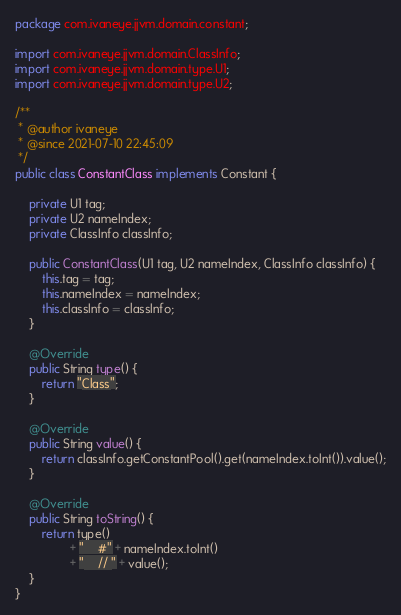<code> <loc_0><loc_0><loc_500><loc_500><_Java_>package com.ivaneye.jjvm.domain.constant;

import com.ivaneye.jjvm.domain.ClassInfo;
import com.ivaneye.jjvm.domain.type.U1;
import com.ivaneye.jjvm.domain.type.U2;

/**
 * @author ivaneye
 * @since 2021-07-10 22:45:09
 */
public class ConstantClass implements Constant {

    private U1 tag;
    private U2 nameIndex;
    private ClassInfo classInfo;

    public ConstantClass(U1 tag, U2 nameIndex, ClassInfo classInfo) {
        this.tag = tag;
        this.nameIndex = nameIndex;
        this.classInfo = classInfo;
    }

    @Override
    public String type() {
        return "Class";
    }

    @Override
    public String value() {
        return classInfo.getConstantPool().get(nameIndex.toInt()).value();
    }

    @Override
    public String toString() {
        return type()
                + "    #" + nameIndex.toInt()
                + "    // " + value();
    }
}
</code> 